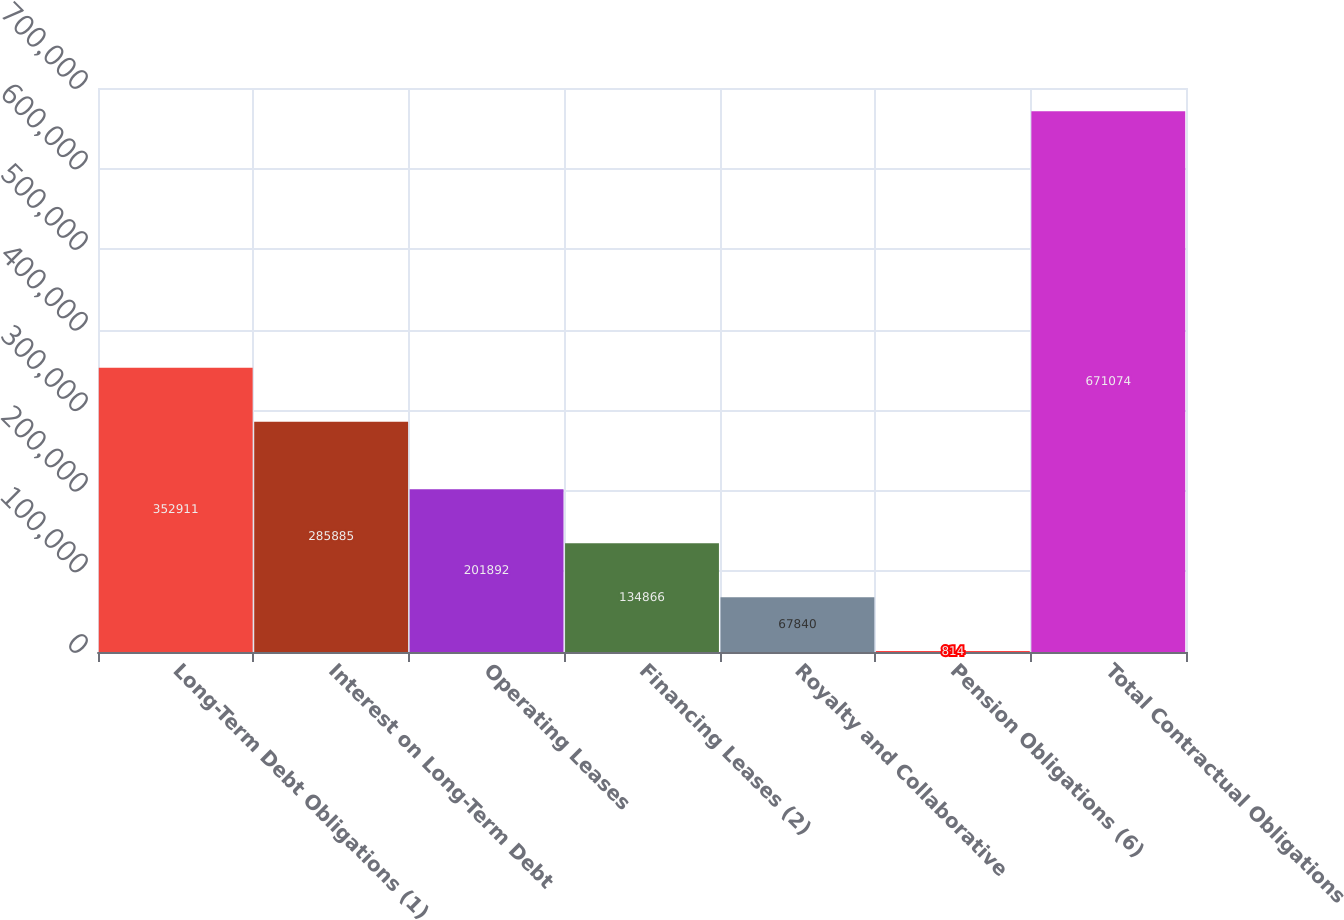Convert chart to OTSL. <chart><loc_0><loc_0><loc_500><loc_500><bar_chart><fcel>Long-Term Debt Obligations (1)<fcel>Interest on Long-Term Debt<fcel>Operating Leases<fcel>Financing Leases (2)<fcel>Royalty and Collaborative<fcel>Pension Obligations (6)<fcel>Total Contractual Obligations<nl><fcel>352911<fcel>285885<fcel>201892<fcel>134866<fcel>67840<fcel>814<fcel>671074<nl></chart> 